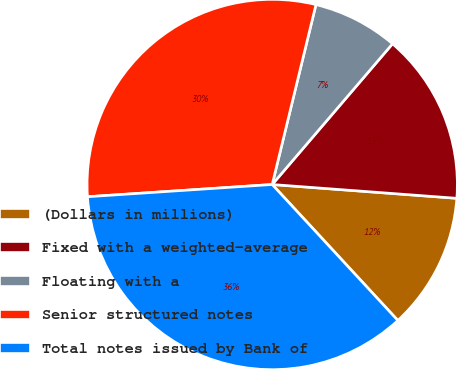<chart> <loc_0><loc_0><loc_500><loc_500><pie_chart><fcel>(Dollars in millions)<fcel>Fixed with a weighted-average<fcel>Floating with a<fcel>Senior structured notes<fcel>Total notes issued by Bank of<nl><fcel>11.94%<fcel>14.93%<fcel>7.46%<fcel>29.85%<fcel>35.82%<nl></chart> 